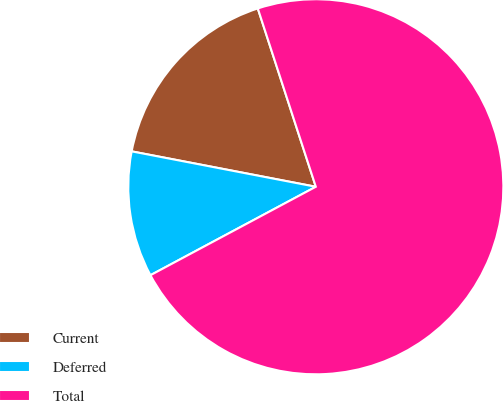Convert chart to OTSL. <chart><loc_0><loc_0><loc_500><loc_500><pie_chart><fcel>Current<fcel>Deferred<fcel>Total<nl><fcel>16.97%<fcel>10.84%<fcel>72.19%<nl></chart> 